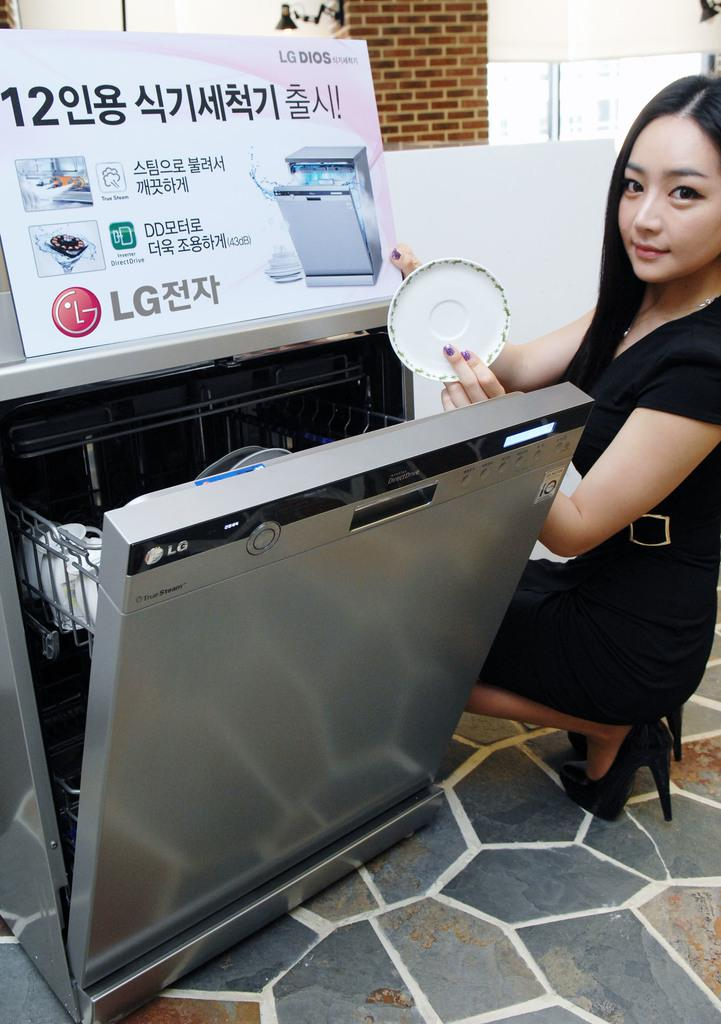<image>
Relay a brief, clear account of the picture shown. the word LG is on the front of the dishwasher 